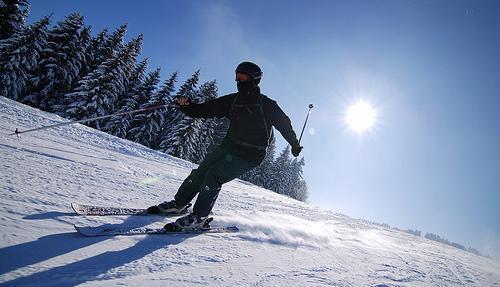How many skiers are in the photo?
Give a very brief answer. 1. 